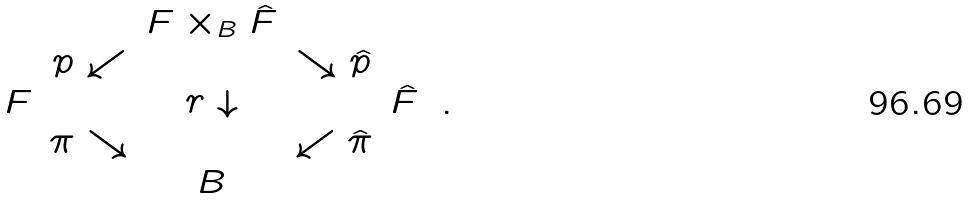<formula> <loc_0><loc_0><loc_500><loc_500>\begin{array} { c c c c c } & & F \times _ { B } \hat { F } & & \\ & p \swarrow & & \searrow \hat { p } \\ F & & r \downarrow & & \hat { F } \\ & \pi \searrow & & \swarrow \hat { \pi } & \\ & & B & & \end{array} \ .</formula> 